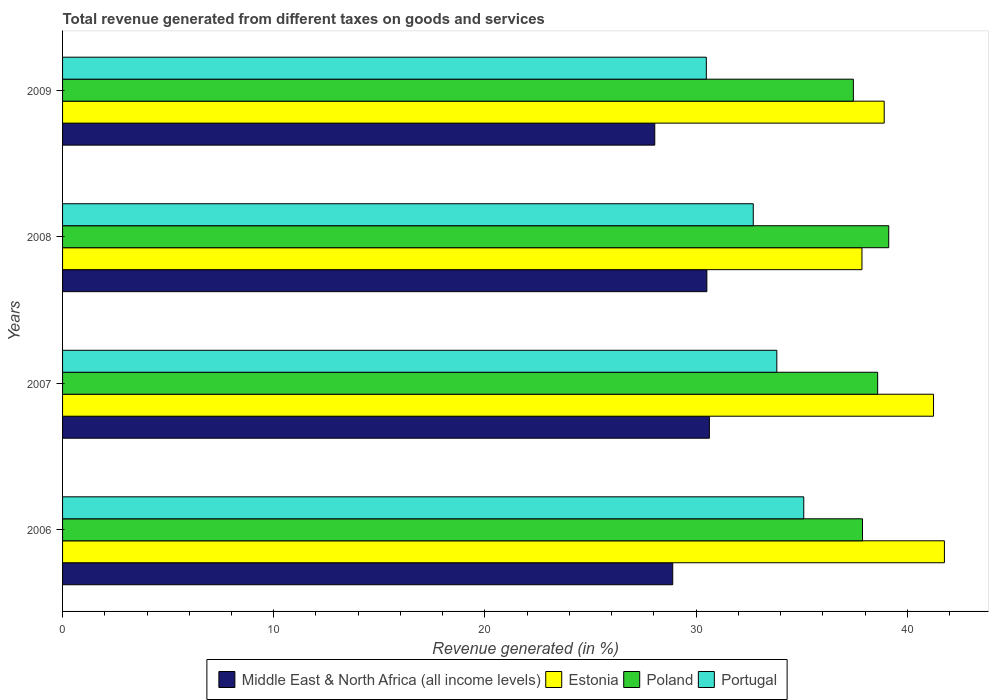How many different coloured bars are there?
Make the answer very short. 4. Are the number of bars on each tick of the Y-axis equal?
Offer a very short reply. Yes. In how many cases, is the number of bars for a given year not equal to the number of legend labels?
Offer a terse response. 0. What is the total revenue generated in Poland in 2006?
Provide a succinct answer. 37.88. Across all years, what is the maximum total revenue generated in Portugal?
Ensure brevity in your answer.  35.1. Across all years, what is the minimum total revenue generated in Portugal?
Offer a terse response. 30.48. In which year was the total revenue generated in Poland minimum?
Give a very brief answer. 2009. What is the total total revenue generated in Middle East & North Africa (all income levels) in the graph?
Your answer should be compact. 118.07. What is the difference between the total revenue generated in Middle East & North Africa (all income levels) in 2006 and that in 2008?
Offer a very short reply. -1.62. What is the difference between the total revenue generated in Poland in 2006 and the total revenue generated in Portugal in 2009?
Offer a very short reply. 7.4. What is the average total revenue generated in Poland per year?
Your answer should be very brief. 38.26. In the year 2009, what is the difference between the total revenue generated in Estonia and total revenue generated in Middle East & North Africa (all income levels)?
Your response must be concise. 10.86. In how many years, is the total revenue generated in Poland greater than 24 %?
Ensure brevity in your answer.  4. What is the ratio of the total revenue generated in Estonia in 2007 to that in 2008?
Your answer should be compact. 1.09. Is the total revenue generated in Middle East & North Africa (all income levels) in 2006 less than that in 2007?
Make the answer very short. Yes. Is the difference between the total revenue generated in Estonia in 2006 and 2009 greater than the difference between the total revenue generated in Middle East & North Africa (all income levels) in 2006 and 2009?
Offer a terse response. Yes. What is the difference between the highest and the second highest total revenue generated in Portugal?
Offer a very short reply. 1.28. What is the difference between the highest and the lowest total revenue generated in Poland?
Keep it short and to the point. 1.68. Is the sum of the total revenue generated in Poland in 2006 and 2009 greater than the maximum total revenue generated in Portugal across all years?
Offer a very short reply. Yes. What does the 2nd bar from the top in 2006 represents?
Provide a succinct answer. Poland. What does the 1st bar from the bottom in 2008 represents?
Provide a short and direct response. Middle East & North Africa (all income levels). Are all the bars in the graph horizontal?
Make the answer very short. Yes. What is the difference between two consecutive major ticks on the X-axis?
Make the answer very short. 10. Are the values on the major ticks of X-axis written in scientific E-notation?
Your answer should be compact. No. Does the graph contain any zero values?
Your response must be concise. No. Does the graph contain grids?
Your answer should be compact. No. How many legend labels are there?
Your answer should be very brief. 4. What is the title of the graph?
Make the answer very short. Total revenue generated from different taxes on goods and services. Does "Yemen, Rep." appear as one of the legend labels in the graph?
Give a very brief answer. No. What is the label or title of the X-axis?
Keep it short and to the point. Revenue generated (in %). What is the label or title of the Y-axis?
Give a very brief answer. Years. What is the Revenue generated (in %) in Middle East & North Africa (all income levels) in 2006?
Provide a short and direct response. 28.89. What is the Revenue generated (in %) in Estonia in 2006?
Offer a terse response. 41.76. What is the Revenue generated (in %) of Poland in 2006?
Provide a short and direct response. 37.88. What is the Revenue generated (in %) in Portugal in 2006?
Provide a short and direct response. 35.1. What is the Revenue generated (in %) of Middle East & North Africa (all income levels) in 2007?
Your answer should be very brief. 30.63. What is the Revenue generated (in %) of Estonia in 2007?
Ensure brevity in your answer.  41.24. What is the Revenue generated (in %) in Poland in 2007?
Your response must be concise. 38.6. What is the Revenue generated (in %) in Portugal in 2007?
Your answer should be compact. 33.82. What is the Revenue generated (in %) in Middle East & North Africa (all income levels) in 2008?
Provide a short and direct response. 30.51. What is the Revenue generated (in %) in Estonia in 2008?
Offer a terse response. 37.85. What is the Revenue generated (in %) of Poland in 2008?
Your answer should be compact. 39.12. What is the Revenue generated (in %) of Portugal in 2008?
Your answer should be compact. 32.71. What is the Revenue generated (in %) of Middle East & North Africa (all income levels) in 2009?
Keep it short and to the point. 28.04. What is the Revenue generated (in %) in Estonia in 2009?
Keep it short and to the point. 38.91. What is the Revenue generated (in %) in Poland in 2009?
Your response must be concise. 37.45. What is the Revenue generated (in %) in Portugal in 2009?
Your answer should be very brief. 30.48. Across all years, what is the maximum Revenue generated (in %) in Middle East & North Africa (all income levels)?
Your response must be concise. 30.63. Across all years, what is the maximum Revenue generated (in %) in Estonia?
Provide a succinct answer. 41.76. Across all years, what is the maximum Revenue generated (in %) in Poland?
Ensure brevity in your answer.  39.12. Across all years, what is the maximum Revenue generated (in %) of Portugal?
Make the answer very short. 35.1. Across all years, what is the minimum Revenue generated (in %) in Middle East & North Africa (all income levels)?
Ensure brevity in your answer.  28.04. Across all years, what is the minimum Revenue generated (in %) of Estonia?
Provide a succinct answer. 37.85. Across all years, what is the minimum Revenue generated (in %) in Poland?
Provide a succinct answer. 37.45. Across all years, what is the minimum Revenue generated (in %) of Portugal?
Provide a short and direct response. 30.48. What is the total Revenue generated (in %) of Middle East & North Africa (all income levels) in the graph?
Give a very brief answer. 118.07. What is the total Revenue generated (in %) of Estonia in the graph?
Provide a short and direct response. 159.76. What is the total Revenue generated (in %) of Poland in the graph?
Give a very brief answer. 153.04. What is the total Revenue generated (in %) in Portugal in the graph?
Make the answer very short. 132.11. What is the difference between the Revenue generated (in %) of Middle East & North Africa (all income levels) in 2006 and that in 2007?
Your answer should be very brief. -1.74. What is the difference between the Revenue generated (in %) in Estonia in 2006 and that in 2007?
Your response must be concise. 0.51. What is the difference between the Revenue generated (in %) in Poland in 2006 and that in 2007?
Your response must be concise. -0.72. What is the difference between the Revenue generated (in %) in Portugal in 2006 and that in 2007?
Your answer should be compact. 1.28. What is the difference between the Revenue generated (in %) of Middle East & North Africa (all income levels) in 2006 and that in 2008?
Your response must be concise. -1.62. What is the difference between the Revenue generated (in %) in Estonia in 2006 and that in 2008?
Keep it short and to the point. 3.9. What is the difference between the Revenue generated (in %) in Poland in 2006 and that in 2008?
Offer a very short reply. -1.24. What is the difference between the Revenue generated (in %) of Portugal in 2006 and that in 2008?
Your answer should be compact. 2.39. What is the difference between the Revenue generated (in %) of Middle East & North Africa (all income levels) in 2006 and that in 2009?
Give a very brief answer. 0.85. What is the difference between the Revenue generated (in %) in Estonia in 2006 and that in 2009?
Keep it short and to the point. 2.85. What is the difference between the Revenue generated (in %) of Poland in 2006 and that in 2009?
Your response must be concise. 0.43. What is the difference between the Revenue generated (in %) of Portugal in 2006 and that in 2009?
Keep it short and to the point. 4.61. What is the difference between the Revenue generated (in %) of Middle East & North Africa (all income levels) in 2007 and that in 2008?
Provide a short and direct response. 0.12. What is the difference between the Revenue generated (in %) in Estonia in 2007 and that in 2008?
Ensure brevity in your answer.  3.39. What is the difference between the Revenue generated (in %) of Poland in 2007 and that in 2008?
Your answer should be very brief. -0.52. What is the difference between the Revenue generated (in %) in Portugal in 2007 and that in 2008?
Make the answer very short. 1.12. What is the difference between the Revenue generated (in %) of Middle East & North Africa (all income levels) in 2007 and that in 2009?
Keep it short and to the point. 2.59. What is the difference between the Revenue generated (in %) of Estonia in 2007 and that in 2009?
Make the answer very short. 2.34. What is the difference between the Revenue generated (in %) in Poland in 2007 and that in 2009?
Your answer should be compact. 1.15. What is the difference between the Revenue generated (in %) of Portugal in 2007 and that in 2009?
Provide a succinct answer. 3.34. What is the difference between the Revenue generated (in %) of Middle East & North Africa (all income levels) in 2008 and that in 2009?
Provide a succinct answer. 2.47. What is the difference between the Revenue generated (in %) in Estonia in 2008 and that in 2009?
Offer a terse response. -1.05. What is the difference between the Revenue generated (in %) in Poland in 2008 and that in 2009?
Offer a terse response. 1.68. What is the difference between the Revenue generated (in %) in Portugal in 2008 and that in 2009?
Your answer should be very brief. 2.22. What is the difference between the Revenue generated (in %) of Middle East & North Africa (all income levels) in 2006 and the Revenue generated (in %) of Estonia in 2007?
Provide a succinct answer. -12.35. What is the difference between the Revenue generated (in %) in Middle East & North Africa (all income levels) in 2006 and the Revenue generated (in %) in Poland in 2007?
Ensure brevity in your answer.  -9.7. What is the difference between the Revenue generated (in %) in Middle East & North Africa (all income levels) in 2006 and the Revenue generated (in %) in Portugal in 2007?
Your response must be concise. -4.93. What is the difference between the Revenue generated (in %) in Estonia in 2006 and the Revenue generated (in %) in Poland in 2007?
Your answer should be compact. 3.16. What is the difference between the Revenue generated (in %) in Estonia in 2006 and the Revenue generated (in %) in Portugal in 2007?
Keep it short and to the point. 7.94. What is the difference between the Revenue generated (in %) in Poland in 2006 and the Revenue generated (in %) in Portugal in 2007?
Make the answer very short. 4.06. What is the difference between the Revenue generated (in %) of Middle East & North Africa (all income levels) in 2006 and the Revenue generated (in %) of Estonia in 2008?
Offer a terse response. -8.96. What is the difference between the Revenue generated (in %) of Middle East & North Africa (all income levels) in 2006 and the Revenue generated (in %) of Poland in 2008?
Offer a very short reply. -10.23. What is the difference between the Revenue generated (in %) in Middle East & North Africa (all income levels) in 2006 and the Revenue generated (in %) in Portugal in 2008?
Offer a terse response. -3.81. What is the difference between the Revenue generated (in %) of Estonia in 2006 and the Revenue generated (in %) of Poland in 2008?
Your answer should be compact. 2.64. What is the difference between the Revenue generated (in %) in Estonia in 2006 and the Revenue generated (in %) in Portugal in 2008?
Give a very brief answer. 9.05. What is the difference between the Revenue generated (in %) of Poland in 2006 and the Revenue generated (in %) of Portugal in 2008?
Ensure brevity in your answer.  5.17. What is the difference between the Revenue generated (in %) of Middle East & North Africa (all income levels) in 2006 and the Revenue generated (in %) of Estonia in 2009?
Make the answer very short. -10.01. What is the difference between the Revenue generated (in %) of Middle East & North Africa (all income levels) in 2006 and the Revenue generated (in %) of Poland in 2009?
Provide a succinct answer. -8.55. What is the difference between the Revenue generated (in %) in Middle East & North Africa (all income levels) in 2006 and the Revenue generated (in %) in Portugal in 2009?
Keep it short and to the point. -1.59. What is the difference between the Revenue generated (in %) in Estonia in 2006 and the Revenue generated (in %) in Poland in 2009?
Offer a terse response. 4.31. What is the difference between the Revenue generated (in %) of Estonia in 2006 and the Revenue generated (in %) of Portugal in 2009?
Your response must be concise. 11.27. What is the difference between the Revenue generated (in %) in Poland in 2006 and the Revenue generated (in %) in Portugal in 2009?
Provide a succinct answer. 7.4. What is the difference between the Revenue generated (in %) of Middle East & North Africa (all income levels) in 2007 and the Revenue generated (in %) of Estonia in 2008?
Ensure brevity in your answer.  -7.22. What is the difference between the Revenue generated (in %) in Middle East & North Africa (all income levels) in 2007 and the Revenue generated (in %) in Poland in 2008?
Make the answer very short. -8.49. What is the difference between the Revenue generated (in %) in Middle East & North Africa (all income levels) in 2007 and the Revenue generated (in %) in Portugal in 2008?
Your answer should be very brief. -2.08. What is the difference between the Revenue generated (in %) of Estonia in 2007 and the Revenue generated (in %) of Poland in 2008?
Keep it short and to the point. 2.12. What is the difference between the Revenue generated (in %) of Estonia in 2007 and the Revenue generated (in %) of Portugal in 2008?
Keep it short and to the point. 8.54. What is the difference between the Revenue generated (in %) in Poland in 2007 and the Revenue generated (in %) in Portugal in 2008?
Ensure brevity in your answer.  5.89. What is the difference between the Revenue generated (in %) of Middle East & North Africa (all income levels) in 2007 and the Revenue generated (in %) of Estonia in 2009?
Your answer should be compact. -8.28. What is the difference between the Revenue generated (in %) in Middle East & North Africa (all income levels) in 2007 and the Revenue generated (in %) in Poland in 2009?
Your answer should be very brief. -6.82. What is the difference between the Revenue generated (in %) of Middle East & North Africa (all income levels) in 2007 and the Revenue generated (in %) of Portugal in 2009?
Give a very brief answer. 0.14. What is the difference between the Revenue generated (in %) in Estonia in 2007 and the Revenue generated (in %) in Poland in 2009?
Provide a short and direct response. 3.8. What is the difference between the Revenue generated (in %) in Estonia in 2007 and the Revenue generated (in %) in Portugal in 2009?
Your answer should be very brief. 10.76. What is the difference between the Revenue generated (in %) of Poland in 2007 and the Revenue generated (in %) of Portugal in 2009?
Your answer should be very brief. 8.11. What is the difference between the Revenue generated (in %) in Middle East & North Africa (all income levels) in 2008 and the Revenue generated (in %) in Estonia in 2009?
Ensure brevity in your answer.  -8.4. What is the difference between the Revenue generated (in %) in Middle East & North Africa (all income levels) in 2008 and the Revenue generated (in %) in Poland in 2009?
Provide a short and direct response. -6.94. What is the difference between the Revenue generated (in %) of Middle East & North Africa (all income levels) in 2008 and the Revenue generated (in %) of Portugal in 2009?
Your response must be concise. 0.03. What is the difference between the Revenue generated (in %) in Estonia in 2008 and the Revenue generated (in %) in Poland in 2009?
Make the answer very short. 0.41. What is the difference between the Revenue generated (in %) of Estonia in 2008 and the Revenue generated (in %) of Portugal in 2009?
Provide a short and direct response. 7.37. What is the difference between the Revenue generated (in %) of Poland in 2008 and the Revenue generated (in %) of Portugal in 2009?
Offer a terse response. 8.64. What is the average Revenue generated (in %) in Middle East & North Africa (all income levels) per year?
Offer a terse response. 29.52. What is the average Revenue generated (in %) of Estonia per year?
Keep it short and to the point. 39.94. What is the average Revenue generated (in %) of Poland per year?
Offer a very short reply. 38.26. What is the average Revenue generated (in %) of Portugal per year?
Your response must be concise. 33.03. In the year 2006, what is the difference between the Revenue generated (in %) in Middle East & North Africa (all income levels) and Revenue generated (in %) in Estonia?
Give a very brief answer. -12.86. In the year 2006, what is the difference between the Revenue generated (in %) in Middle East & North Africa (all income levels) and Revenue generated (in %) in Poland?
Give a very brief answer. -8.99. In the year 2006, what is the difference between the Revenue generated (in %) in Middle East & North Africa (all income levels) and Revenue generated (in %) in Portugal?
Ensure brevity in your answer.  -6.2. In the year 2006, what is the difference between the Revenue generated (in %) of Estonia and Revenue generated (in %) of Poland?
Ensure brevity in your answer.  3.88. In the year 2006, what is the difference between the Revenue generated (in %) in Estonia and Revenue generated (in %) in Portugal?
Offer a very short reply. 6.66. In the year 2006, what is the difference between the Revenue generated (in %) in Poland and Revenue generated (in %) in Portugal?
Provide a succinct answer. 2.78. In the year 2007, what is the difference between the Revenue generated (in %) in Middle East & North Africa (all income levels) and Revenue generated (in %) in Estonia?
Make the answer very short. -10.61. In the year 2007, what is the difference between the Revenue generated (in %) in Middle East & North Africa (all income levels) and Revenue generated (in %) in Poland?
Offer a terse response. -7.97. In the year 2007, what is the difference between the Revenue generated (in %) of Middle East & North Africa (all income levels) and Revenue generated (in %) of Portugal?
Make the answer very short. -3.19. In the year 2007, what is the difference between the Revenue generated (in %) of Estonia and Revenue generated (in %) of Poland?
Provide a short and direct response. 2.65. In the year 2007, what is the difference between the Revenue generated (in %) in Estonia and Revenue generated (in %) in Portugal?
Provide a succinct answer. 7.42. In the year 2007, what is the difference between the Revenue generated (in %) of Poland and Revenue generated (in %) of Portugal?
Your answer should be compact. 4.78. In the year 2008, what is the difference between the Revenue generated (in %) of Middle East & North Africa (all income levels) and Revenue generated (in %) of Estonia?
Make the answer very short. -7.34. In the year 2008, what is the difference between the Revenue generated (in %) of Middle East & North Africa (all income levels) and Revenue generated (in %) of Poland?
Provide a succinct answer. -8.61. In the year 2008, what is the difference between the Revenue generated (in %) of Middle East & North Africa (all income levels) and Revenue generated (in %) of Portugal?
Your response must be concise. -2.2. In the year 2008, what is the difference between the Revenue generated (in %) of Estonia and Revenue generated (in %) of Poland?
Keep it short and to the point. -1.27. In the year 2008, what is the difference between the Revenue generated (in %) of Estonia and Revenue generated (in %) of Portugal?
Keep it short and to the point. 5.15. In the year 2008, what is the difference between the Revenue generated (in %) of Poland and Revenue generated (in %) of Portugal?
Your answer should be compact. 6.41. In the year 2009, what is the difference between the Revenue generated (in %) of Middle East & North Africa (all income levels) and Revenue generated (in %) of Estonia?
Offer a very short reply. -10.86. In the year 2009, what is the difference between the Revenue generated (in %) in Middle East & North Africa (all income levels) and Revenue generated (in %) in Poland?
Offer a terse response. -9.4. In the year 2009, what is the difference between the Revenue generated (in %) in Middle East & North Africa (all income levels) and Revenue generated (in %) in Portugal?
Your answer should be very brief. -2.44. In the year 2009, what is the difference between the Revenue generated (in %) in Estonia and Revenue generated (in %) in Poland?
Keep it short and to the point. 1.46. In the year 2009, what is the difference between the Revenue generated (in %) of Estonia and Revenue generated (in %) of Portugal?
Offer a terse response. 8.42. In the year 2009, what is the difference between the Revenue generated (in %) of Poland and Revenue generated (in %) of Portugal?
Make the answer very short. 6.96. What is the ratio of the Revenue generated (in %) of Middle East & North Africa (all income levels) in 2006 to that in 2007?
Provide a succinct answer. 0.94. What is the ratio of the Revenue generated (in %) in Estonia in 2006 to that in 2007?
Give a very brief answer. 1.01. What is the ratio of the Revenue generated (in %) of Poland in 2006 to that in 2007?
Ensure brevity in your answer.  0.98. What is the ratio of the Revenue generated (in %) of Portugal in 2006 to that in 2007?
Provide a succinct answer. 1.04. What is the ratio of the Revenue generated (in %) of Middle East & North Africa (all income levels) in 2006 to that in 2008?
Make the answer very short. 0.95. What is the ratio of the Revenue generated (in %) of Estonia in 2006 to that in 2008?
Offer a terse response. 1.1. What is the ratio of the Revenue generated (in %) of Poland in 2006 to that in 2008?
Keep it short and to the point. 0.97. What is the ratio of the Revenue generated (in %) of Portugal in 2006 to that in 2008?
Give a very brief answer. 1.07. What is the ratio of the Revenue generated (in %) in Middle East & North Africa (all income levels) in 2006 to that in 2009?
Ensure brevity in your answer.  1.03. What is the ratio of the Revenue generated (in %) in Estonia in 2006 to that in 2009?
Make the answer very short. 1.07. What is the ratio of the Revenue generated (in %) of Poland in 2006 to that in 2009?
Give a very brief answer. 1.01. What is the ratio of the Revenue generated (in %) of Portugal in 2006 to that in 2009?
Your answer should be compact. 1.15. What is the ratio of the Revenue generated (in %) of Estonia in 2007 to that in 2008?
Provide a succinct answer. 1.09. What is the ratio of the Revenue generated (in %) of Poland in 2007 to that in 2008?
Provide a short and direct response. 0.99. What is the ratio of the Revenue generated (in %) of Portugal in 2007 to that in 2008?
Offer a terse response. 1.03. What is the ratio of the Revenue generated (in %) in Middle East & North Africa (all income levels) in 2007 to that in 2009?
Offer a very short reply. 1.09. What is the ratio of the Revenue generated (in %) in Estonia in 2007 to that in 2009?
Provide a succinct answer. 1.06. What is the ratio of the Revenue generated (in %) of Poland in 2007 to that in 2009?
Your answer should be very brief. 1.03. What is the ratio of the Revenue generated (in %) of Portugal in 2007 to that in 2009?
Give a very brief answer. 1.11. What is the ratio of the Revenue generated (in %) of Middle East & North Africa (all income levels) in 2008 to that in 2009?
Offer a very short reply. 1.09. What is the ratio of the Revenue generated (in %) of Estonia in 2008 to that in 2009?
Offer a terse response. 0.97. What is the ratio of the Revenue generated (in %) in Poland in 2008 to that in 2009?
Provide a succinct answer. 1.04. What is the ratio of the Revenue generated (in %) in Portugal in 2008 to that in 2009?
Provide a succinct answer. 1.07. What is the difference between the highest and the second highest Revenue generated (in %) in Middle East & North Africa (all income levels)?
Provide a succinct answer. 0.12. What is the difference between the highest and the second highest Revenue generated (in %) in Estonia?
Keep it short and to the point. 0.51. What is the difference between the highest and the second highest Revenue generated (in %) in Poland?
Give a very brief answer. 0.52. What is the difference between the highest and the second highest Revenue generated (in %) of Portugal?
Provide a succinct answer. 1.28. What is the difference between the highest and the lowest Revenue generated (in %) of Middle East & North Africa (all income levels)?
Make the answer very short. 2.59. What is the difference between the highest and the lowest Revenue generated (in %) of Estonia?
Provide a short and direct response. 3.9. What is the difference between the highest and the lowest Revenue generated (in %) in Poland?
Provide a short and direct response. 1.68. What is the difference between the highest and the lowest Revenue generated (in %) of Portugal?
Make the answer very short. 4.61. 